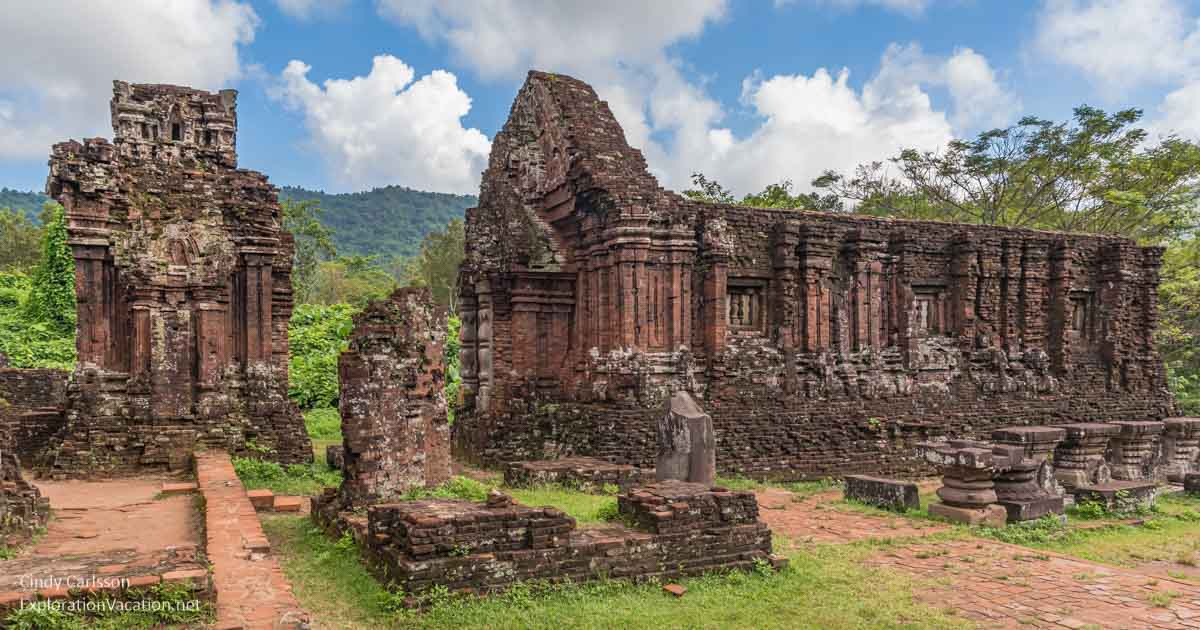How does this site compare to other ancient temple complexes around the world? The My Son temple complex, while unique in its cultural and historical context, shares similarities with other ancient temple complexes worldwide, such as Cambodia’s Angkor Wat and India’s Khajuraho. Like these sites, My Son boasts distinctive architectural styles and intricate carvings reflective of its religious significance. While Angkor Wat is famed for its massive scale and grandeur, and Khajuraho for its detailed erotic sculptures, My Son represents the artistic and spiritual heritage of the Champa kingdom. Each site provides a unique window into the ancient civilizations that built them, offering valuable insights into their religious practices, social structures, and artistic achievements. 